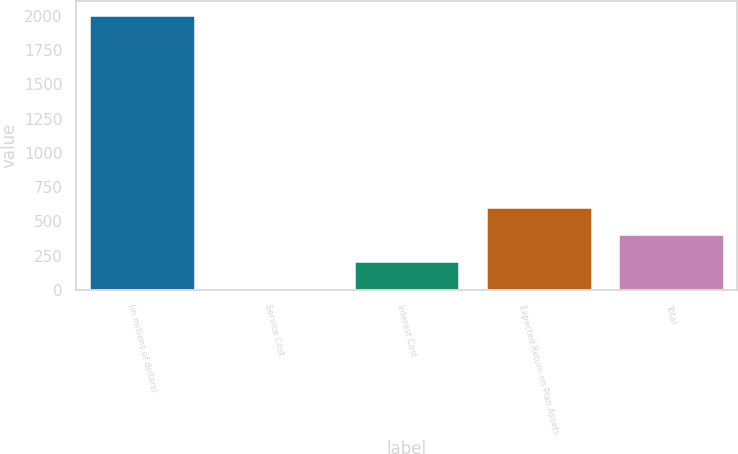<chart> <loc_0><loc_0><loc_500><loc_500><bar_chart><fcel>(in millions of dollars)<fcel>Service Cost<fcel>Interest Cost<fcel>Expected Return on Plan Assets<fcel>Total<nl><fcel>2007<fcel>9.2<fcel>208.98<fcel>608.54<fcel>408.76<nl></chart> 